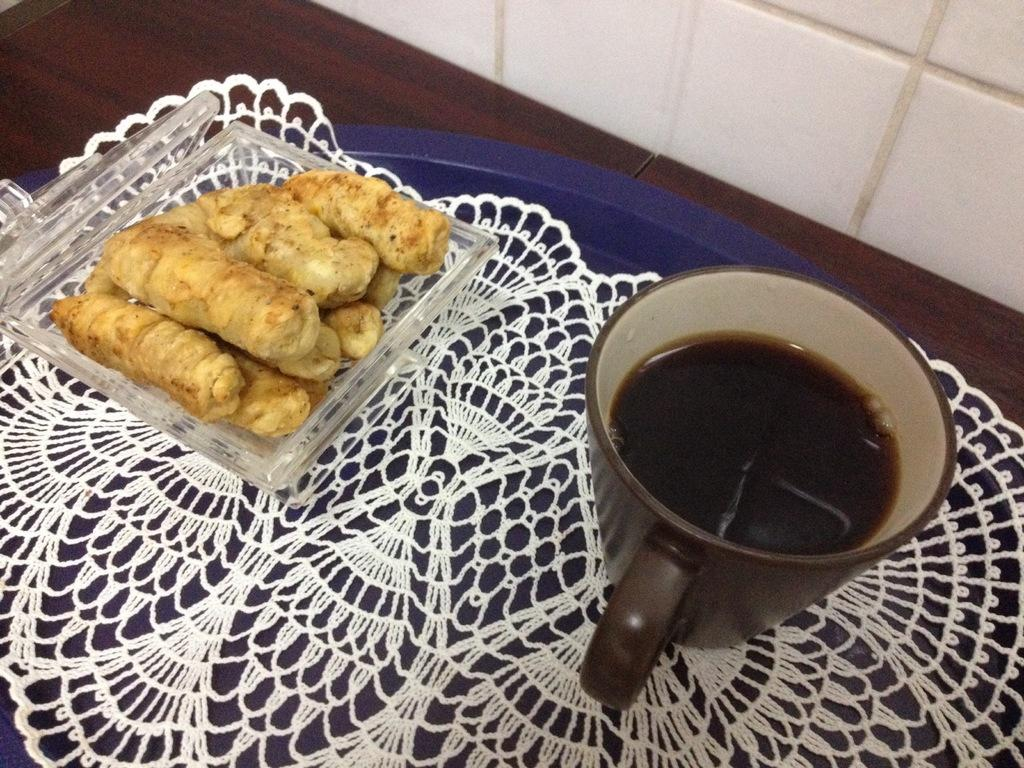What is present on the table in the image? There are food items on the table in the image. What can be seen in the background of the image? There is a wall visible in the background of the image. Can you see a stream flowing through the room in the image? There is no stream visible in the image; it features food items on a table and a wall in the background. 